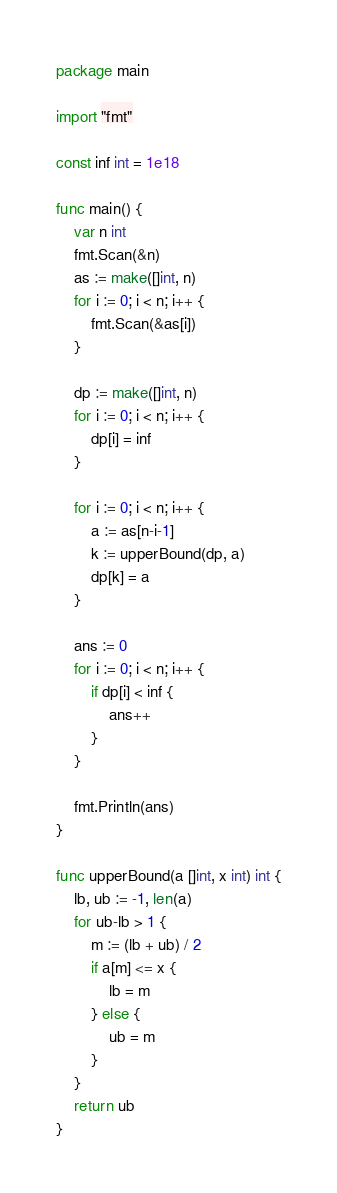Convert code to text. <code><loc_0><loc_0><loc_500><loc_500><_Go_>package main

import "fmt"

const inf int = 1e18

func main() {
	var n int
	fmt.Scan(&n)
	as := make([]int, n)
	for i := 0; i < n; i++ {
		fmt.Scan(&as[i])
	}

	dp := make([]int, n)
	for i := 0; i < n; i++ {
		dp[i] = inf
	}

	for i := 0; i < n; i++ {
		a := as[n-i-1]
		k := upperBound(dp, a)
		dp[k] = a
	}

	ans := 0
	for i := 0; i < n; i++ {
		if dp[i] < inf {
			ans++
		}
	}

	fmt.Println(ans)
}

func upperBound(a []int, x int) int {
	lb, ub := -1, len(a)
	for ub-lb > 1 {
		m := (lb + ub) / 2
		if a[m] <= x {
			lb = m
		} else {
			ub = m
		}
	}
	return ub
}
</code> 